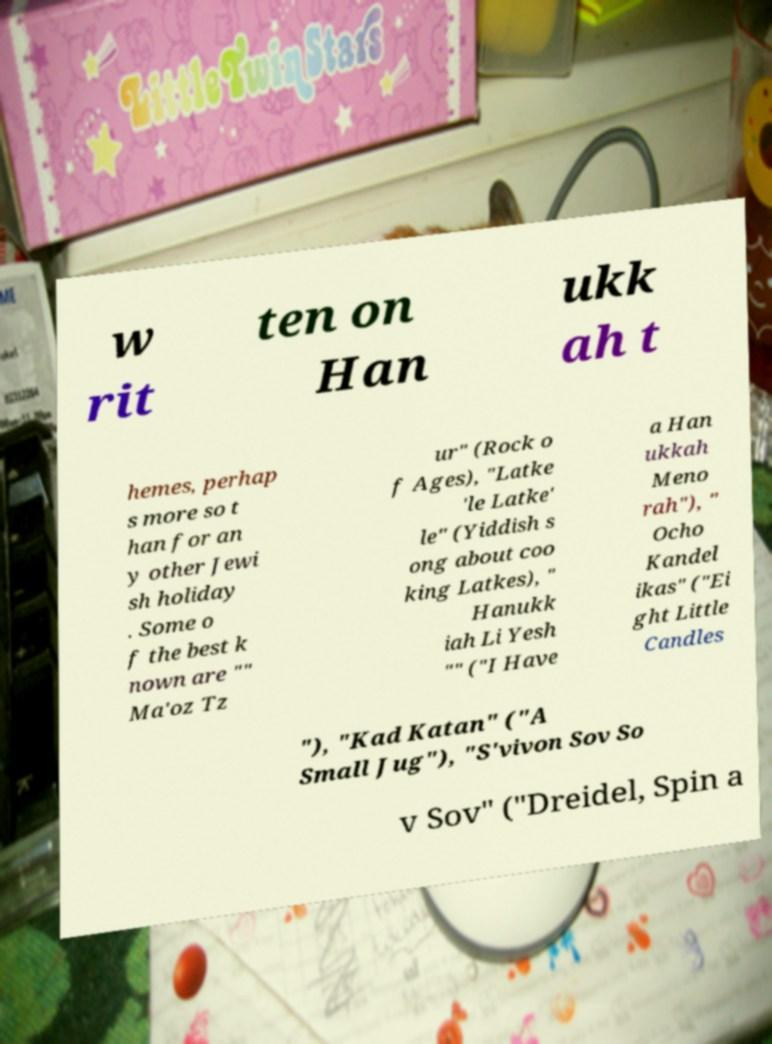Could you extract and type out the text from this image? w rit ten on Han ukk ah t hemes, perhap s more so t han for an y other Jewi sh holiday . Some o f the best k nown are "" Ma'oz Tz ur" (Rock o f Ages), "Latke 'le Latke' le" (Yiddish s ong about coo king Latkes), " Hanukk iah Li Yesh "" ("I Have a Han ukkah Meno rah"), " Ocho Kandel ikas" ("Ei ght Little Candles "), "Kad Katan" ("A Small Jug"), "S'vivon Sov So v Sov" ("Dreidel, Spin a 